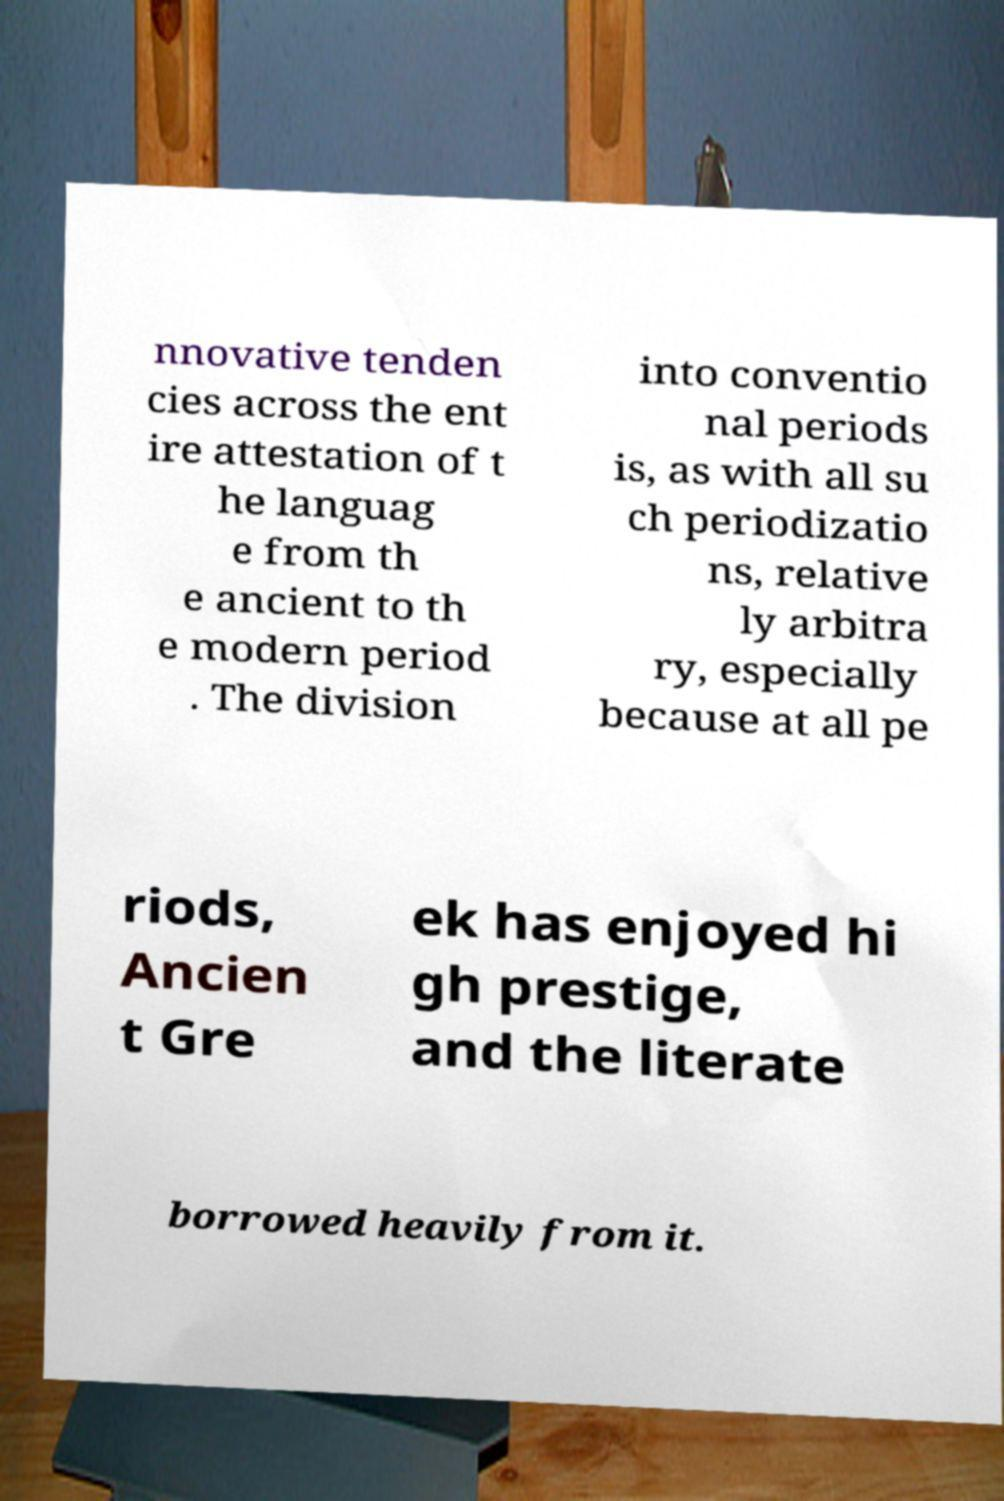Could you extract and type out the text from this image? nnovative tenden cies across the ent ire attestation of t he languag e from th e ancient to th e modern period . The division into conventio nal periods is, as with all su ch periodizatio ns, relative ly arbitra ry, especially because at all pe riods, Ancien t Gre ek has enjoyed hi gh prestige, and the literate borrowed heavily from it. 